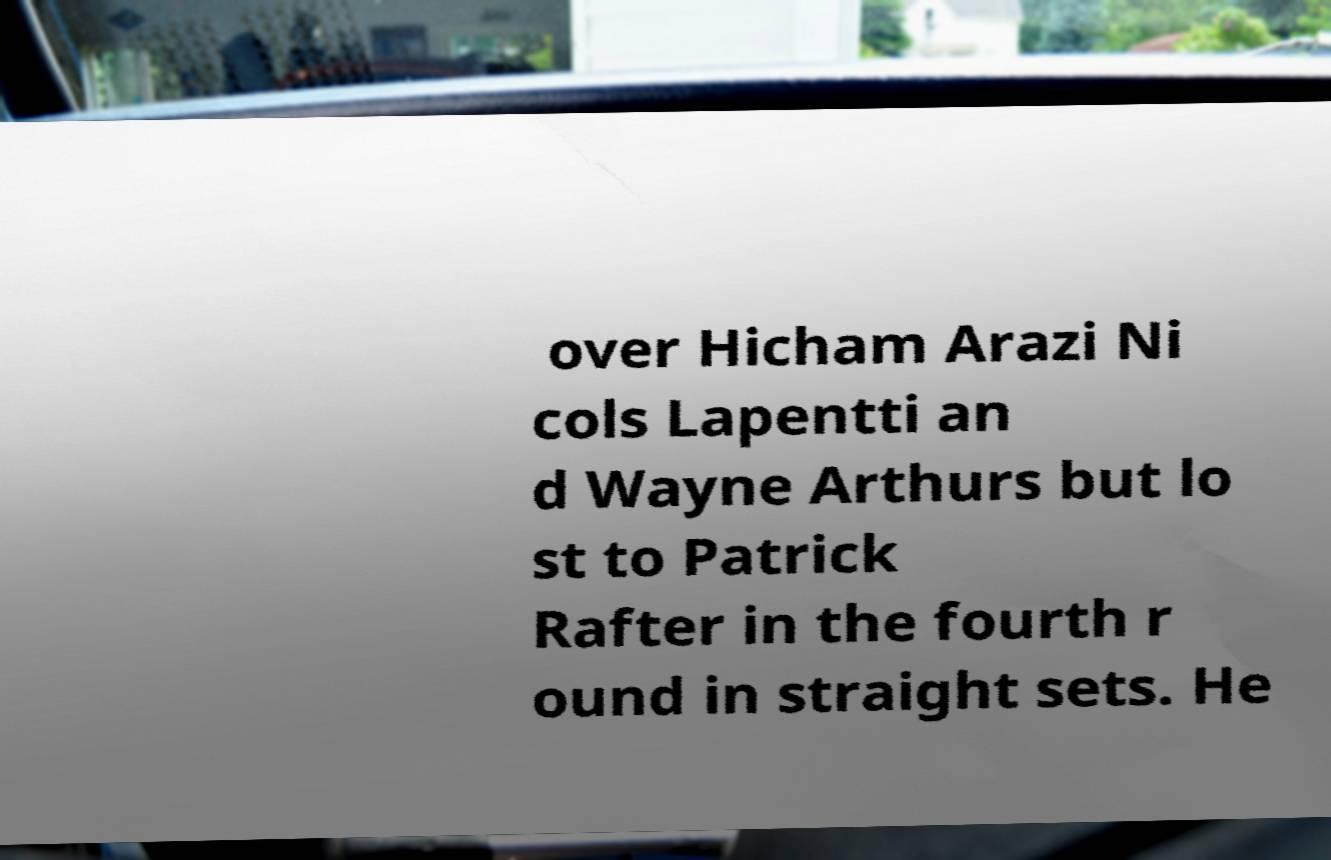Could you extract and type out the text from this image? over Hicham Arazi Ni cols Lapentti an d Wayne Arthurs but lo st to Patrick Rafter in the fourth r ound in straight sets. He 